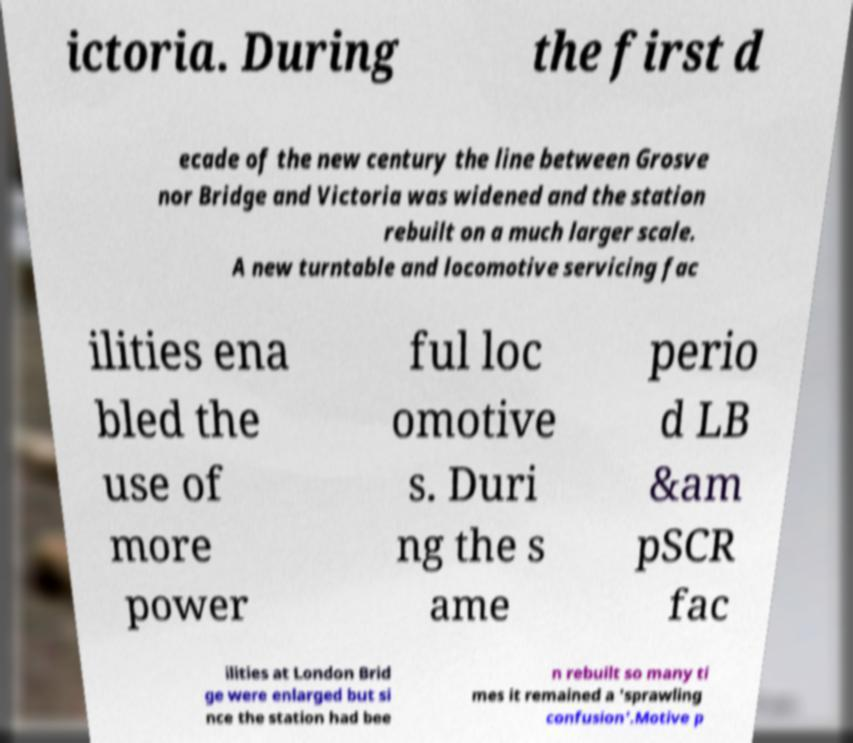Please identify and transcribe the text found in this image. ictoria. During the first d ecade of the new century the line between Grosve nor Bridge and Victoria was widened and the station rebuilt on a much larger scale. A new turntable and locomotive servicing fac ilities ena bled the use of more power ful loc omotive s. Duri ng the s ame perio d LB &am pSCR fac ilities at London Brid ge were enlarged but si nce the station had bee n rebuilt so many ti mes it remained a 'sprawling confusion'.Motive p 